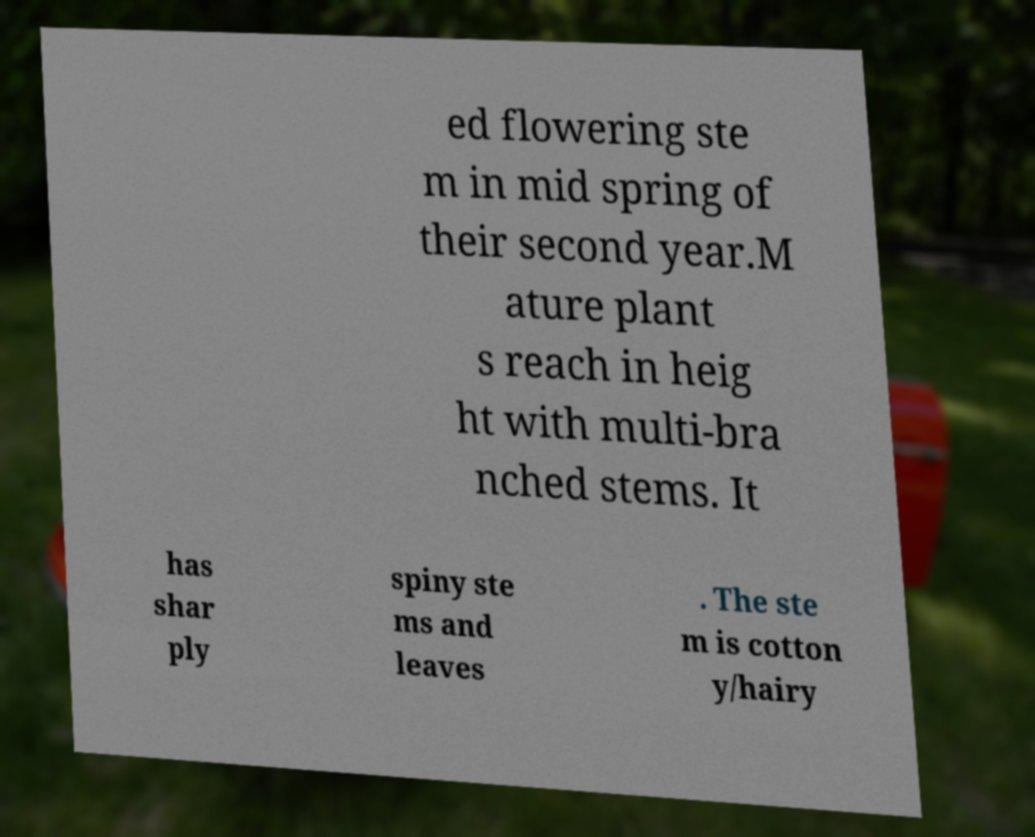Please identify and transcribe the text found in this image. ed flowering ste m in mid spring of their second year.M ature plant s reach in heig ht with multi-bra nched stems. It has shar ply spiny ste ms and leaves . The ste m is cotton y/hairy 